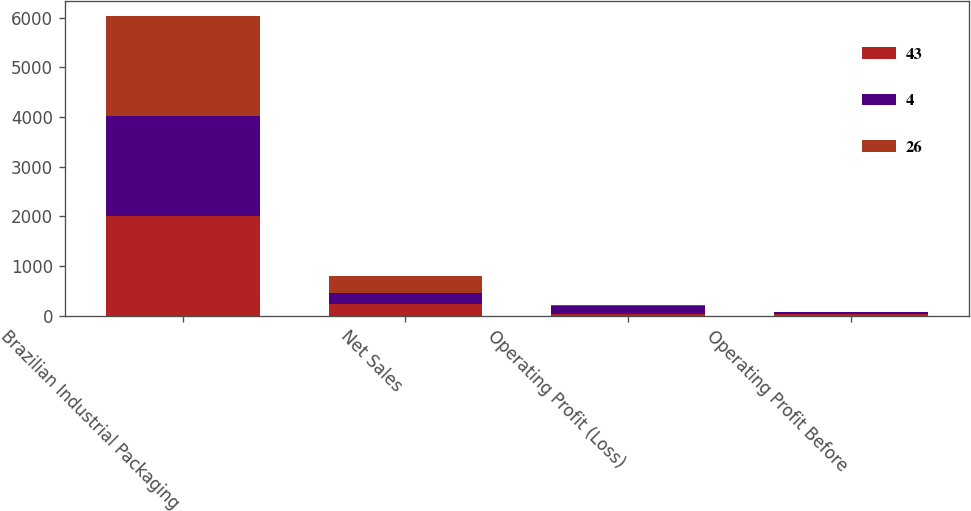Convert chart. <chart><loc_0><loc_0><loc_500><loc_500><stacked_bar_chart><ecel><fcel>Brazilian Industrial Packaging<fcel>Net Sales<fcel>Operating Profit (Loss)<fcel>Operating Profit Before<nl><fcel>43<fcel>2016<fcel>232<fcel>43<fcel>43<nl><fcel>4<fcel>2015<fcel>228<fcel>163<fcel>26<nl><fcel>26<fcel>2014<fcel>349<fcel>3<fcel>4<nl></chart> 